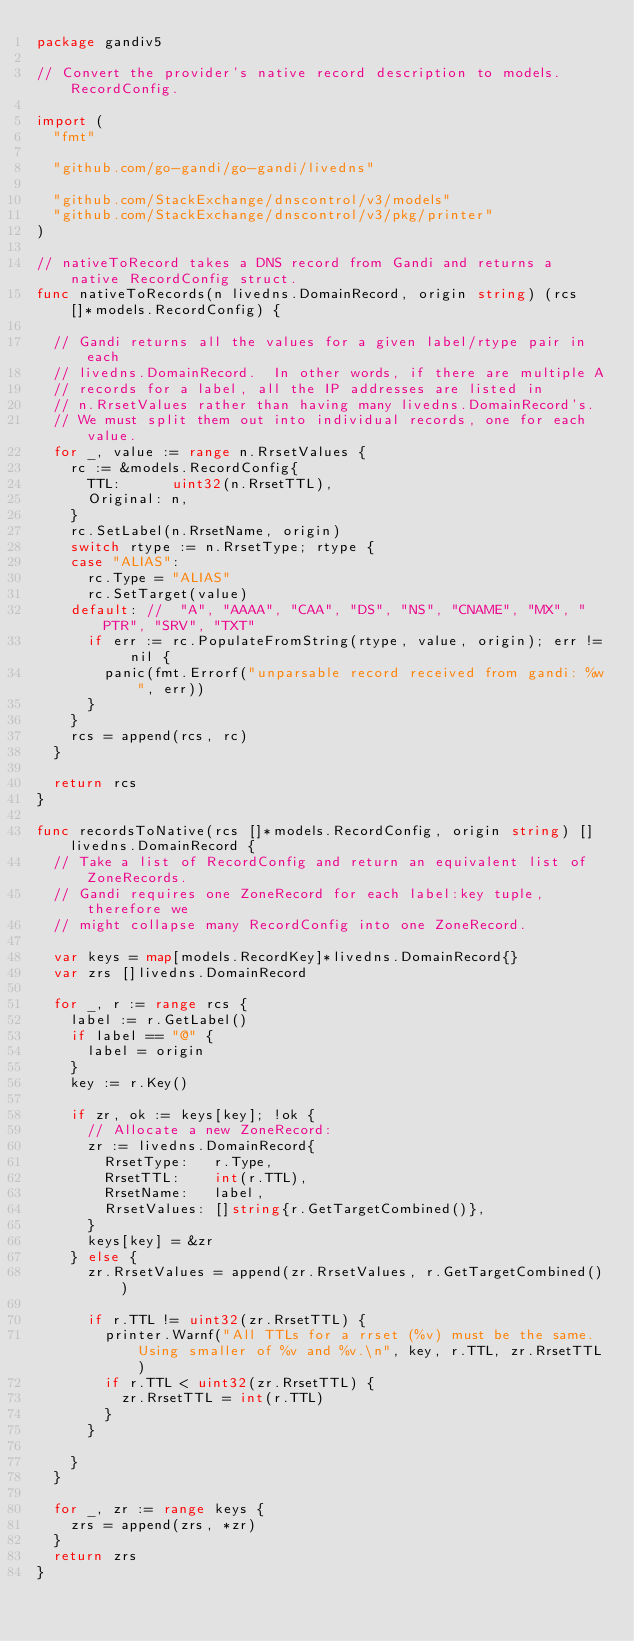<code> <loc_0><loc_0><loc_500><loc_500><_Go_>package gandiv5

// Convert the provider's native record description to models.RecordConfig.

import (
	"fmt"

	"github.com/go-gandi/go-gandi/livedns"

	"github.com/StackExchange/dnscontrol/v3/models"
	"github.com/StackExchange/dnscontrol/v3/pkg/printer"
)

// nativeToRecord takes a DNS record from Gandi and returns a native RecordConfig struct.
func nativeToRecords(n livedns.DomainRecord, origin string) (rcs []*models.RecordConfig) {

	// Gandi returns all the values for a given label/rtype pair in each
	// livedns.DomainRecord.  In other words, if there are multiple A
	// records for a label, all the IP addresses are listed in
	// n.RrsetValues rather than having many livedns.DomainRecord's.
	// We must split them out into individual records, one for each value.
	for _, value := range n.RrsetValues {
		rc := &models.RecordConfig{
			TTL:      uint32(n.RrsetTTL),
			Original: n,
		}
		rc.SetLabel(n.RrsetName, origin)
		switch rtype := n.RrsetType; rtype {
		case "ALIAS":
			rc.Type = "ALIAS"
			rc.SetTarget(value)
		default: //  "A", "AAAA", "CAA", "DS", "NS", "CNAME", "MX", "PTR", "SRV", "TXT"
			if err := rc.PopulateFromString(rtype, value, origin); err != nil {
				panic(fmt.Errorf("unparsable record received from gandi: %w", err))
			}
		}
		rcs = append(rcs, rc)
	}

	return rcs
}

func recordsToNative(rcs []*models.RecordConfig, origin string) []livedns.DomainRecord {
	// Take a list of RecordConfig and return an equivalent list of ZoneRecords.
	// Gandi requires one ZoneRecord for each label:key tuple, therefore we
	// might collapse many RecordConfig into one ZoneRecord.

	var keys = map[models.RecordKey]*livedns.DomainRecord{}
	var zrs []livedns.DomainRecord

	for _, r := range rcs {
		label := r.GetLabel()
		if label == "@" {
			label = origin
		}
		key := r.Key()

		if zr, ok := keys[key]; !ok {
			// Allocate a new ZoneRecord:
			zr := livedns.DomainRecord{
				RrsetType:   r.Type,
				RrsetTTL:    int(r.TTL),
				RrsetName:   label,
				RrsetValues: []string{r.GetTargetCombined()},
			}
			keys[key] = &zr
		} else {
			zr.RrsetValues = append(zr.RrsetValues, r.GetTargetCombined())

			if r.TTL != uint32(zr.RrsetTTL) {
				printer.Warnf("All TTLs for a rrset (%v) must be the same. Using smaller of %v and %v.\n", key, r.TTL, zr.RrsetTTL)
				if r.TTL < uint32(zr.RrsetTTL) {
					zr.RrsetTTL = int(r.TTL)
				}
			}

		}
	}

	for _, zr := range keys {
		zrs = append(zrs, *zr)
	}
	return zrs
}
</code> 